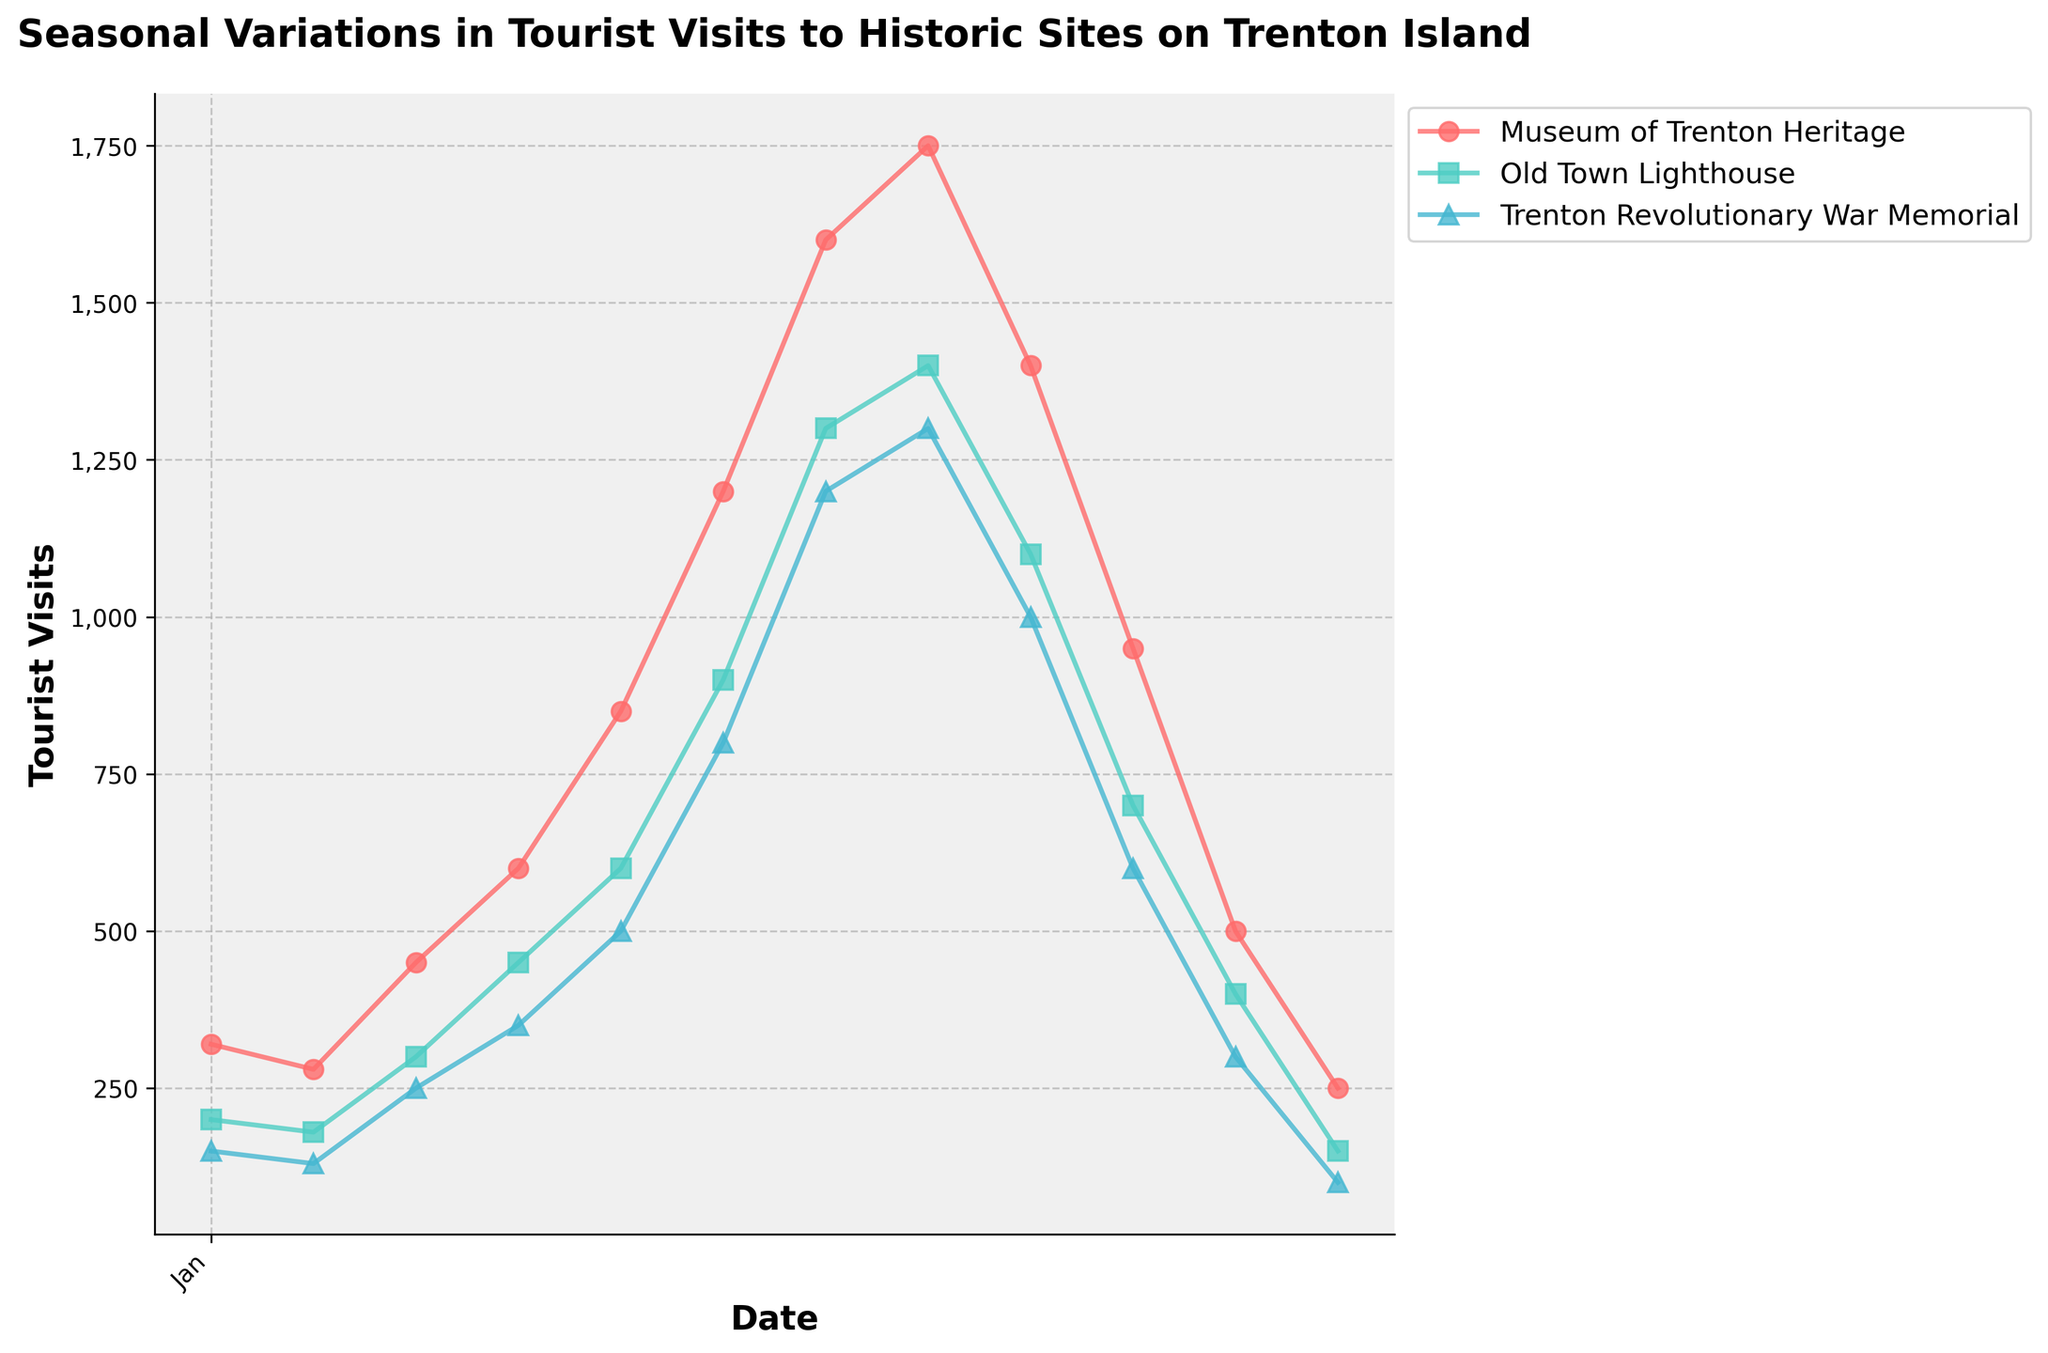What's the title of the figure? Look at the top of the plot where the title is located.
Answer: Seasonal Variations in Tourist Visits to Historic Sites on Trenton Island How many historic sites are plotted in the figure? Count the number of distinct lines or legends labeling different historic sites.
Answer: 3 During which month does the Museum of Trenton Heritage receive the highest number of tourists? Identify the peak point on the line for the Museum of Trenton Heritage and check the corresponding month on the x-axis.
Answer: August What is the general trend of tourist visits to all historic sites from January to December? Observe the lines for all three historic sites from the beginning to the end of the year.
Answer: Increase in summer, peak in July/August, and decrease towards December Which historic site has the lowest number of tourist visits in December? Look for the lowest point among the markers for December across all the historic sites.
Answer: Trenton Revolutionary War Memorial Compare the total number of tourist visits in July between the Museum of Trenton Heritage and Old Town Lighthouse. Find the values for both sites in July and sum them up: 1600 (Museum of Trenton Heritage) and 1300 (Old Town Lighthouse).
Answer: Museum of Trenton Heritage: 1600, Old Town Lighthouse: 1300 In which month is the difference in tourist visits between Old Town Lighthouse and Trenton Revolutionary War Memorial the greatest? Calculate the difference in tourist visits for each month and determine the maximum difference.
Answer: August How does the number of tourist visits in May compare between the three historic sites? Identify the tourist visits for each site in May and compare.
Answer: Museum of Trenton Heritage: 850, Old Town Lighthouse: 600, Trenton Revolutionary War Memorial: 500 On average, which quarter sees the highest tourist visits for all three sites combined? Calculate the average number of tourist visits for each site in Q1 (Jan-Mar), Q2 (Apr-Jun), Q3 (Jul-Sep), Q4 (Oct-Dec) and compare them to find the highest.
Answer: Q3 What is the range of tourist visits (difference between the highest and lowest values) for Trenton Revolutionary War Memorial? Identify the highest (August: 1300) and lowest (December: 100) tourist visits. Calculate the difference: 1300 - 100.
Answer: 1200 